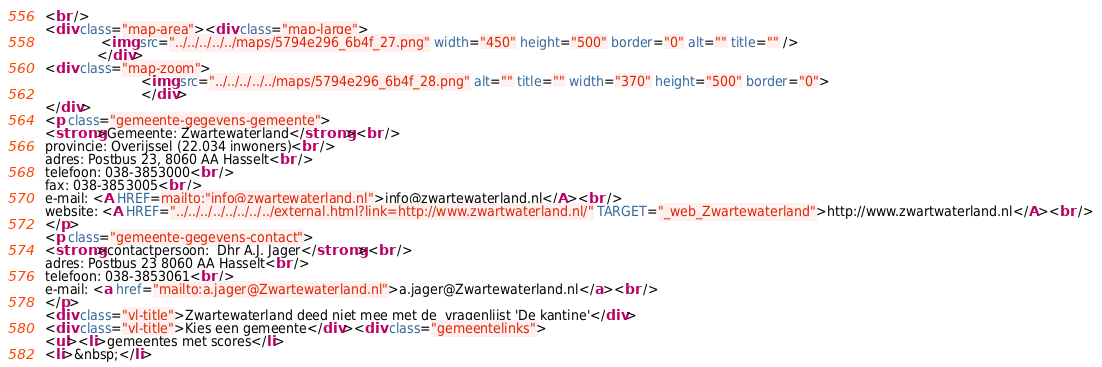<code> <loc_0><loc_0><loc_500><loc_500><_HTML_><br />
<div class="map-area"><div class="map-large">
              <img src="../../../../../maps/5794e296_6b4f_27.png" width="450" height="500" border="0" alt="" title="" />
             </div>
<div class="map-zoom">
                        <img src="../../../../../maps/5794e296_6b4f_28.png" alt="" title="" width="370" height="500" border="0">
                        </div>
</div>
<p class="gemeente-gegevens-gemeente">
<strong>Gemeente: Zwartewaterland</strong><br />
provincie: Overijssel (22.034 inwoners)<br />
adres: Postbus 23, 8060 AA Hasselt<br />
telefoon: 038-3853000<br />
fax: 038-3853005<br />
e-mail: <A HREF=mailto:"info@zwartewaterland.nl">info@zwartewaterland.nl</A><br />
website: <A HREF="../../../../../../../../external.html?link=http://www.zwartwaterland.nl/" TARGET="_web_Zwartewaterland">http://www.zwartwaterland.nl</A><br />
</p>
<p class="gemeente-gegevens-contact">
<strong>contactpersoon:  Dhr A.J. Jager</strong><br />
adres: Postbus 23 8060 AA Hasselt<br />
telefoon: 038-3853061<br />
e-mail: <a href="mailto:a.jager@Zwartewaterland.nl">a.jager@Zwartewaterland.nl</a><br />
</p>
<div class="vl-title">Zwartewaterland deed niet mee met de  vragenlijst 'De kantine'</div>
<div class="vl-title">Kies een gemeente</div><div class="gemeentelinks">
<ul><li>gemeentes met scores</li>
<li>&nbsp;</li></code> 